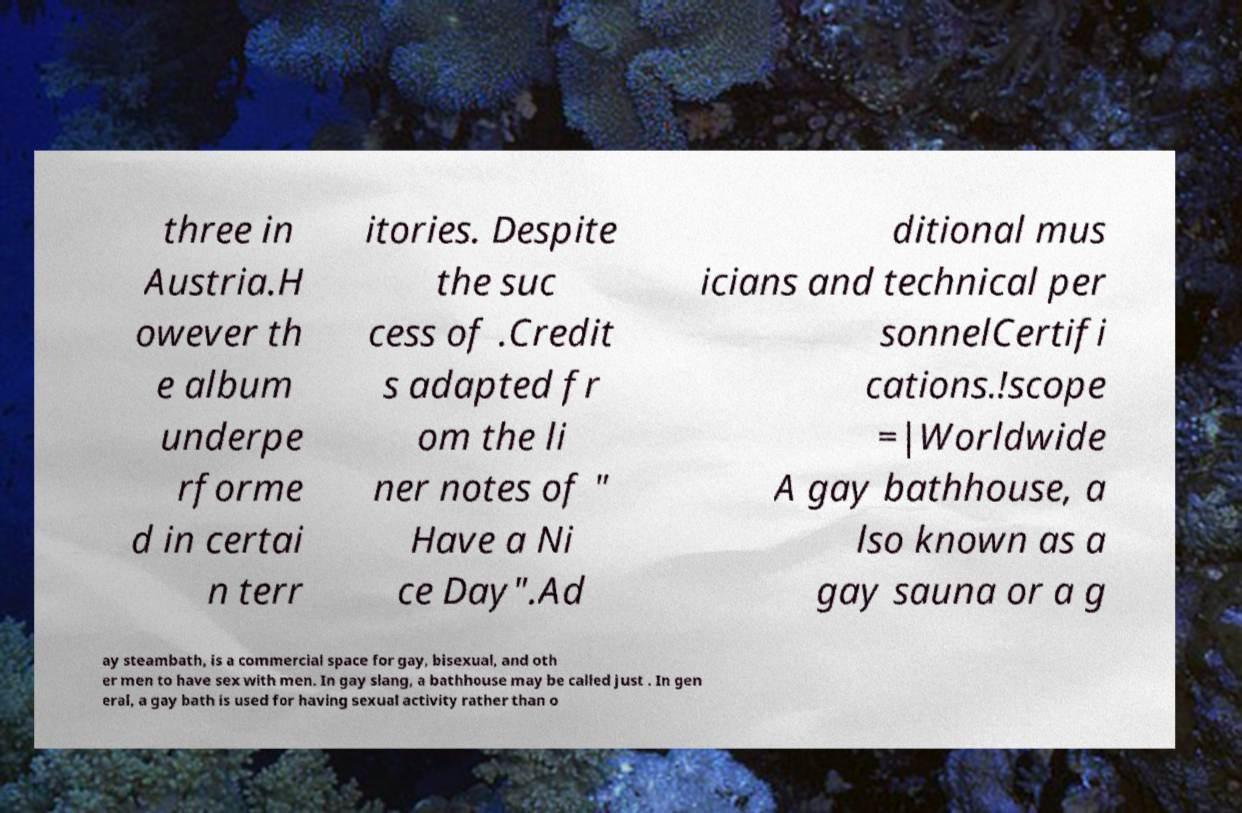Could you assist in decoding the text presented in this image and type it out clearly? three in Austria.H owever th e album underpe rforme d in certai n terr itories. Despite the suc cess of .Credit s adapted fr om the li ner notes of " Have a Ni ce Day".Ad ditional mus icians and technical per sonnelCertifi cations.!scope =|Worldwide A gay bathhouse, a lso known as a gay sauna or a g ay steambath, is a commercial space for gay, bisexual, and oth er men to have sex with men. In gay slang, a bathhouse may be called just . In gen eral, a gay bath is used for having sexual activity rather than o 